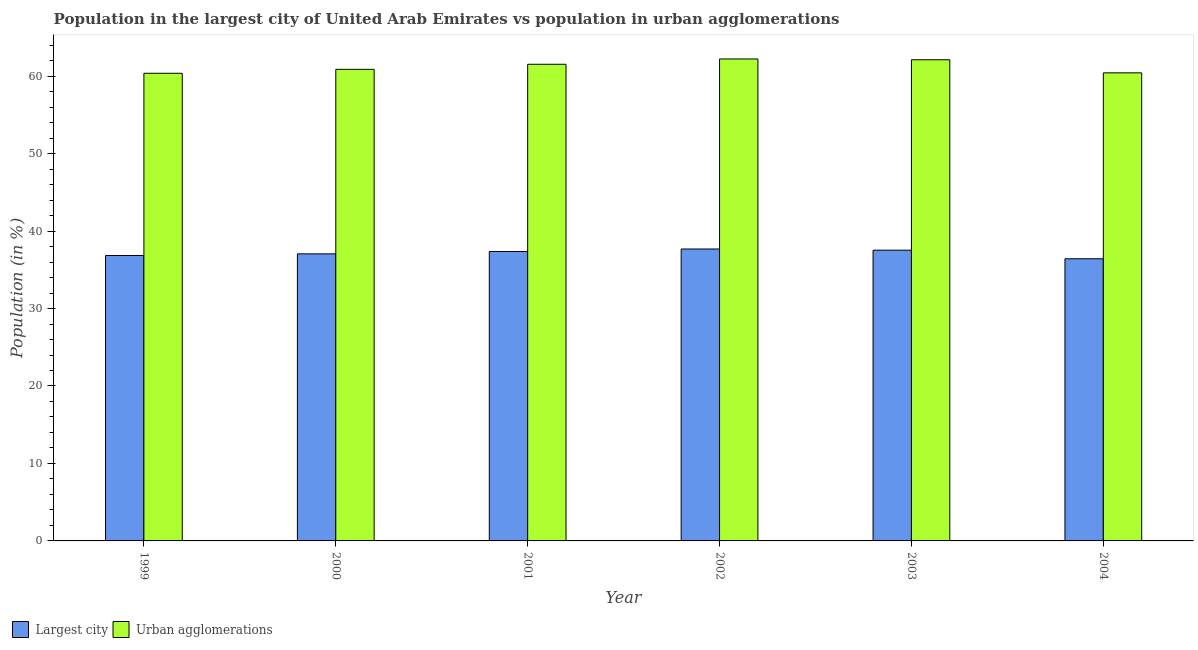Are the number of bars per tick equal to the number of legend labels?
Ensure brevity in your answer.  Yes. Are the number of bars on each tick of the X-axis equal?
Your answer should be very brief. Yes. What is the label of the 3rd group of bars from the left?
Provide a succinct answer. 2001. In how many cases, is the number of bars for a given year not equal to the number of legend labels?
Provide a succinct answer. 0. What is the population in urban agglomerations in 2000?
Your response must be concise. 60.88. Across all years, what is the maximum population in urban agglomerations?
Your response must be concise. 62.22. Across all years, what is the minimum population in the largest city?
Your answer should be very brief. 36.43. In which year was the population in urban agglomerations maximum?
Your answer should be very brief. 2002. What is the total population in the largest city in the graph?
Your answer should be compact. 222.92. What is the difference between the population in the largest city in 2002 and that in 2004?
Keep it short and to the point. 1.26. What is the difference between the population in urban agglomerations in 2004 and the population in the largest city in 2002?
Give a very brief answer. -1.79. What is the average population in the largest city per year?
Give a very brief answer. 37.15. In how many years, is the population in the largest city greater than 44 %?
Keep it short and to the point. 0. What is the ratio of the population in urban agglomerations in 1999 to that in 2004?
Offer a terse response. 1. Is the population in urban agglomerations in 1999 less than that in 2004?
Provide a short and direct response. Yes. What is the difference between the highest and the second highest population in the largest city?
Make the answer very short. 0.15. What is the difference between the highest and the lowest population in urban agglomerations?
Give a very brief answer. 1.85. Is the sum of the population in urban agglomerations in 2000 and 2003 greater than the maximum population in the largest city across all years?
Your response must be concise. Yes. What does the 1st bar from the left in 1999 represents?
Keep it short and to the point. Largest city. What does the 2nd bar from the right in 1999 represents?
Your response must be concise. Largest city. How many bars are there?
Your answer should be compact. 12. What is the difference between two consecutive major ticks on the Y-axis?
Make the answer very short. 10. Are the values on the major ticks of Y-axis written in scientific E-notation?
Your response must be concise. No. Does the graph contain any zero values?
Provide a succinct answer. No. Does the graph contain grids?
Ensure brevity in your answer.  No. What is the title of the graph?
Your response must be concise. Population in the largest city of United Arab Emirates vs population in urban agglomerations. What is the label or title of the X-axis?
Offer a very short reply. Year. What is the label or title of the Y-axis?
Provide a short and direct response. Population (in %). What is the Population (in %) of Largest city in 1999?
Keep it short and to the point. 36.84. What is the Population (in %) in Urban agglomerations in 1999?
Provide a succinct answer. 60.37. What is the Population (in %) in Largest city in 2000?
Provide a short and direct response. 37.06. What is the Population (in %) in Urban agglomerations in 2000?
Give a very brief answer. 60.88. What is the Population (in %) in Largest city in 2001?
Provide a succinct answer. 37.36. What is the Population (in %) in Urban agglomerations in 2001?
Give a very brief answer. 61.53. What is the Population (in %) in Largest city in 2002?
Give a very brief answer. 37.69. What is the Population (in %) in Urban agglomerations in 2002?
Provide a succinct answer. 62.22. What is the Population (in %) of Largest city in 2003?
Ensure brevity in your answer.  37.53. What is the Population (in %) in Urban agglomerations in 2003?
Keep it short and to the point. 62.12. What is the Population (in %) of Largest city in 2004?
Your answer should be very brief. 36.43. What is the Population (in %) in Urban agglomerations in 2004?
Offer a terse response. 60.42. Across all years, what is the maximum Population (in %) of Largest city?
Offer a terse response. 37.69. Across all years, what is the maximum Population (in %) in Urban agglomerations?
Keep it short and to the point. 62.22. Across all years, what is the minimum Population (in %) in Largest city?
Provide a short and direct response. 36.43. Across all years, what is the minimum Population (in %) in Urban agglomerations?
Your response must be concise. 60.37. What is the total Population (in %) of Largest city in the graph?
Give a very brief answer. 222.92. What is the total Population (in %) in Urban agglomerations in the graph?
Your answer should be compact. 367.54. What is the difference between the Population (in %) in Largest city in 1999 and that in 2000?
Keep it short and to the point. -0.22. What is the difference between the Population (in %) in Urban agglomerations in 1999 and that in 2000?
Your answer should be compact. -0.51. What is the difference between the Population (in %) in Largest city in 1999 and that in 2001?
Your answer should be compact. -0.52. What is the difference between the Population (in %) in Urban agglomerations in 1999 and that in 2001?
Your response must be concise. -1.16. What is the difference between the Population (in %) in Largest city in 1999 and that in 2002?
Give a very brief answer. -0.84. What is the difference between the Population (in %) in Urban agglomerations in 1999 and that in 2002?
Ensure brevity in your answer.  -1.85. What is the difference between the Population (in %) of Largest city in 1999 and that in 2003?
Your answer should be very brief. -0.69. What is the difference between the Population (in %) in Urban agglomerations in 1999 and that in 2003?
Keep it short and to the point. -1.75. What is the difference between the Population (in %) in Largest city in 1999 and that in 2004?
Provide a succinct answer. 0.42. What is the difference between the Population (in %) of Urban agglomerations in 1999 and that in 2004?
Make the answer very short. -0.05. What is the difference between the Population (in %) in Largest city in 2000 and that in 2001?
Ensure brevity in your answer.  -0.3. What is the difference between the Population (in %) in Urban agglomerations in 2000 and that in 2001?
Provide a short and direct response. -0.65. What is the difference between the Population (in %) of Largest city in 2000 and that in 2002?
Keep it short and to the point. -0.63. What is the difference between the Population (in %) in Urban agglomerations in 2000 and that in 2002?
Your response must be concise. -1.34. What is the difference between the Population (in %) in Largest city in 2000 and that in 2003?
Keep it short and to the point. -0.47. What is the difference between the Population (in %) in Urban agglomerations in 2000 and that in 2003?
Keep it short and to the point. -1.24. What is the difference between the Population (in %) of Largest city in 2000 and that in 2004?
Your answer should be compact. 0.63. What is the difference between the Population (in %) in Urban agglomerations in 2000 and that in 2004?
Keep it short and to the point. 0.45. What is the difference between the Population (in %) of Largest city in 2001 and that in 2002?
Your answer should be very brief. -0.32. What is the difference between the Population (in %) in Urban agglomerations in 2001 and that in 2002?
Ensure brevity in your answer.  -0.68. What is the difference between the Population (in %) of Largest city in 2001 and that in 2003?
Offer a terse response. -0.17. What is the difference between the Population (in %) in Urban agglomerations in 2001 and that in 2003?
Offer a very short reply. -0.58. What is the difference between the Population (in %) of Largest city in 2001 and that in 2004?
Provide a succinct answer. 0.94. What is the difference between the Population (in %) of Urban agglomerations in 2001 and that in 2004?
Your answer should be very brief. 1.11. What is the difference between the Population (in %) in Largest city in 2002 and that in 2003?
Your response must be concise. 0.15. What is the difference between the Population (in %) in Urban agglomerations in 2002 and that in 2003?
Make the answer very short. 0.1. What is the difference between the Population (in %) in Largest city in 2002 and that in 2004?
Your answer should be compact. 1.26. What is the difference between the Population (in %) of Urban agglomerations in 2002 and that in 2004?
Your answer should be very brief. 1.79. What is the difference between the Population (in %) in Largest city in 2003 and that in 2004?
Provide a succinct answer. 1.11. What is the difference between the Population (in %) in Urban agglomerations in 2003 and that in 2004?
Provide a short and direct response. 1.69. What is the difference between the Population (in %) of Largest city in 1999 and the Population (in %) of Urban agglomerations in 2000?
Your answer should be very brief. -24.03. What is the difference between the Population (in %) of Largest city in 1999 and the Population (in %) of Urban agglomerations in 2001?
Provide a succinct answer. -24.69. What is the difference between the Population (in %) in Largest city in 1999 and the Population (in %) in Urban agglomerations in 2002?
Your answer should be compact. -25.37. What is the difference between the Population (in %) in Largest city in 1999 and the Population (in %) in Urban agglomerations in 2003?
Give a very brief answer. -25.27. What is the difference between the Population (in %) in Largest city in 1999 and the Population (in %) in Urban agglomerations in 2004?
Ensure brevity in your answer.  -23.58. What is the difference between the Population (in %) of Largest city in 2000 and the Population (in %) of Urban agglomerations in 2001?
Your answer should be compact. -24.47. What is the difference between the Population (in %) of Largest city in 2000 and the Population (in %) of Urban agglomerations in 2002?
Your answer should be compact. -25.16. What is the difference between the Population (in %) in Largest city in 2000 and the Population (in %) in Urban agglomerations in 2003?
Your response must be concise. -25.06. What is the difference between the Population (in %) in Largest city in 2000 and the Population (in %) in Urban agglomerations in 2004?
Your answer should be very brief. -23.36. What is the difference between the Population (in %) of Largest city in 2001 and the Population (in %) of Urban agglomerations in 2002?
Your answer should be very brief. -24.85. What is the difference between the Population (in %) in Largest city in 2001 and the Population (in %) in Urban agglomerations in 2003?
Your answer should be very brief. -24.75. What is the difference between the Population (in %) in Largest city in 2001 and the Population (in %) in Urban agglomerations in 2004?
Offer a very short reply. -23.06. What is the difference between the Population (in %) of Largest city in 2002 and the Population (in %) of Urban agglomerations in 2003?
Provide a succinct answer. -24.43. What is the difference between the Population (in %) of Largest city in 2002 and the Population (in %) of Urban agglomerations in 2004?
Your response must be concise. -22.74. What is the difference between the Population (in %) of Largest city in 2003 and the Population (in %) of Urban agglomerations in 2004?
Make the answer very short. -22.89. What is the average Population (in %) of Largest city per year?
Offer a terse response. 37.15. What is the average Population (in %) in Urban agglomerations per year?
Your response must be concise. 61.26. In the year 1999, what is the difference between the Population (in %) of Largest city and Population (in %) of Urban agglomerations?
Offer a very short reply. -23.53. In the year 2000, what is the difference between the Population (in %) of Largest city and Population (in %) of Urban agglomerations?
Your answer should be very brief. -23.82. In the year 2001, what is the difference between the Population (in %) in Largest city and Population (in %) in Urban agglomerations?
Your response must be concise. -24.17. In the year 2002, what is the difference between the Population (in %) in Largest city and Population (in %) in Urban agglomerations?
Give a very brief answer. -24.53. In the year 2003, what is the difference between the Population (in %) of Largest city and Population (in %) of Urban agglomerations?
Your answer should be compact. -24.58. In the year 2004, what is the difference between the Population (in %) in Largest city and Population (in %) in Urban agglomerations?
Offer a very short reply. -24. What is the ratio of the Population (in %) of Largest city in 1999 to that in 2000?
Keep it short and to the point. 0.99. What is the ratio of the Population (in %) of Urban agglomerations in 1999 to that in 2000?
Ensure brevity in your answer.  0.99. What is the ratio of the Population (in %) of Largest city in 1999 to that in 2001?
Ensure brevity in your answer.  0.99. What is the ratio of the Population (in %) of Urban agglomerations in 1999 to that in 2001?
Ensure brevity in your answer.  0.98. What is the ratio of the Population (in %) in Largest city in 1999 to that in 2002?
Provide a succinct answer. 0.98. What is the ratio of the Population (in %) in Urban agglomerations in 1999 to that in 2002?
Make the answer very short. 0.97. What is the ratio of the Population (in %) in Largest city in 1999 to that in 2003?
Your answer should be very brief. 0.98. What is the ratio of the Population (in %) of Urban agglomerations in 1999 to that in 2003?
Ensure brevity in your answer.  0.97. What is the ratio of the Population (in %) in Largest city in 1999 to that in 2004?
Your answer should be compact. 1.01. What is the ratio of the Population (in %) in Largest city in 2000 to that in 2001?
Provide a succinct answer. 0.99. What is the ratio of the Population (in %) of Largest city in 2000 to that in 2002?
Ensure brevity in your answer.  0.98. What is the ratio of the Population (in %) of Urban agglomerations in 2000 to that in 2002?
Provide a short and direct response. 0.98. What is the ratio of the Population (in %) of Largest city in 2000 to that in 2003?
Make the answer very short. 0.99. What is the ratio of the Population (in %) of Urban agglomerations in 2000 to that in 2003?
Offer a terse response. 0.98. What is the ratio of the Population (in %) in Largest city in 2000 to that in 2004?
Keep it short and to the point. 1.02. What is the ratio of the Population (in %) of Urban agglomerations in 2000 to that in 2004?
Provide a succinct answer. 1.01. What is the ratio of the Population (in %) of Urban agglomerations in 2001 to that in 2002?
Offer a terse response. 0.99. What is the ratio of the Population (in %) in Largest city in 2001 to that in 2003?
Make the answer very short. 1. What is the ratio of the Population (in %) of Urban agglomerations in 2001 to that in 2003?
Offer a terse response. 0.99. What is the ratio of the Population (in %) of Largest city in 2001 to that in 2004?
Provide a succinct answer. 1.03. What is the ratio of the Population (in %) in Urban agglomerations in 2001 to that in 2004?
Your answer should be compact. 1.02. What is the ratio of the Population (in %) of Largest city in 2002 to that in 2004?
Keep it short and to the point. 1.03. What is the ratio of the Population (in %) in Urban agglomerations in 2002 to that in 2004?
Give a very brief answer. 1.03. What is the ratio of the Population (in %) in Largest city in 2003 to that in 2004?
Keep it short and to the point. 1.03. What is the ratio of the Population (in %) in Urban agglomerations in 2003 to that in 2004?
Give a very brief answer. 1.03. What is the difference between the highest and the second highest Population (in %) in Largest city?
Your response must be concise. 0.15. What is the difference between the highest and the second highest Population (in %) of Urban agglomerations?
Your response must be concise. 0.1. What is the difference between the highest and the lowest Population (in %) of Largest city?
Give a very brief answer. 1.26. What is the difference between the highest and the lowest Population (in %) in Urban agglomerations?
Provide a short and direct response. 1.85. 